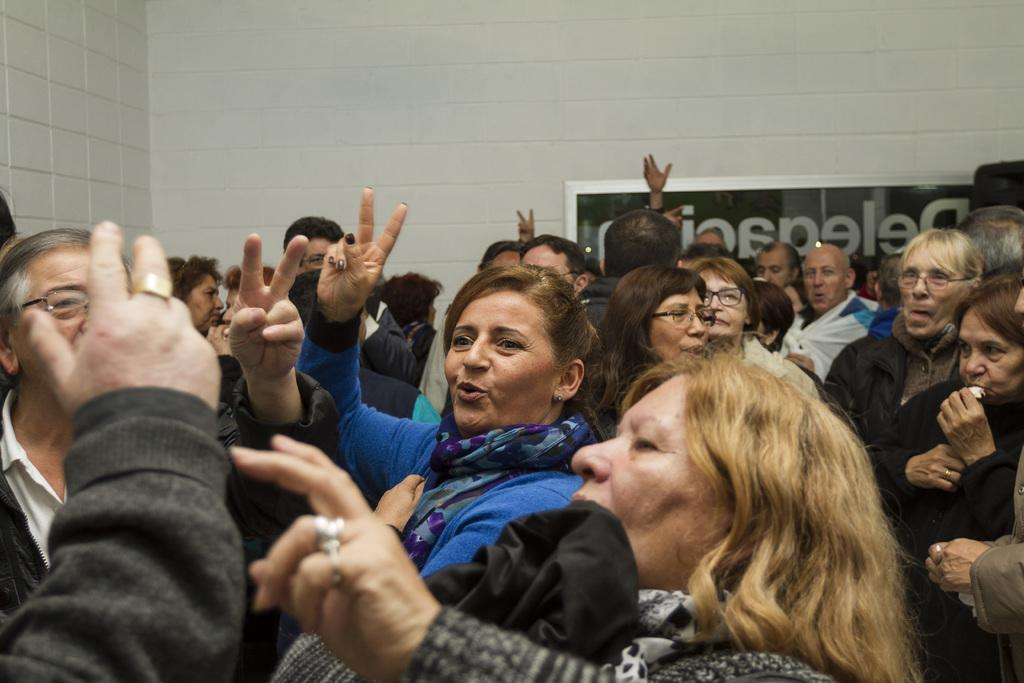Who or what can be seen in the image? There are people in the image. What is visible in the background of the image? There is a white wall in the background. What is on the wall in the image? There is a board on the wall with something written on it. What type of scene is the father creating in the image? There is no father or scene present in the image; it only features people, a white wall, and a board with writing on it. 